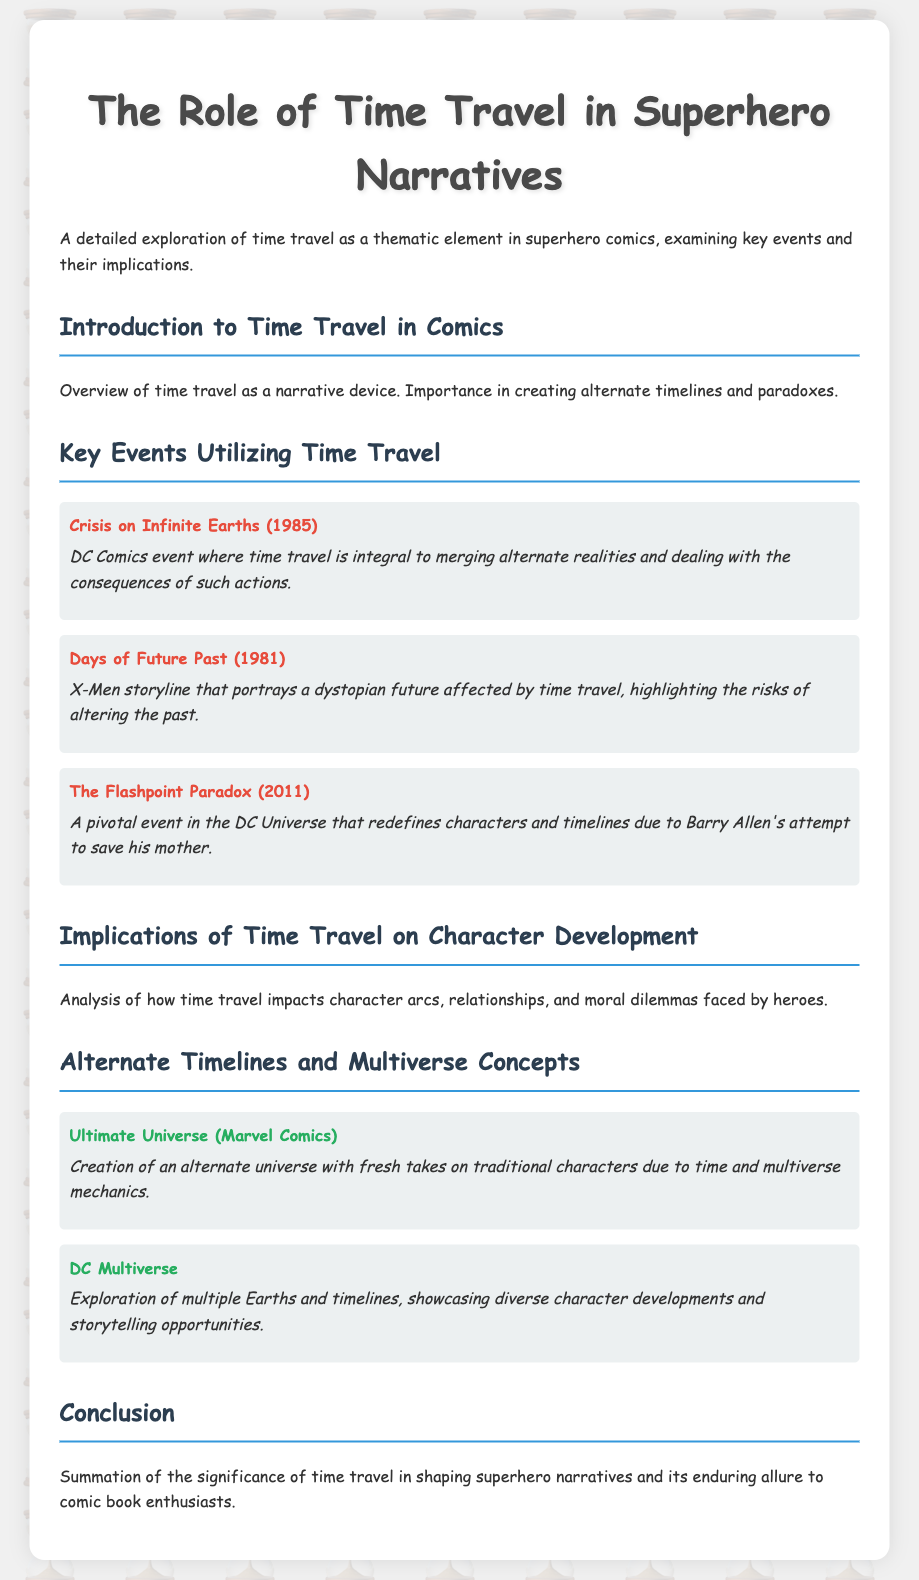What is the title of the document? The title is specified in the header tag of the document.
Answer: The Role of Time Travel in Superhero Narratives What year did the event "Crisis on Infinite Earths" occur? The year of the event is mentioned in the description of key events.
Answer: 1985 Which comic book series features the storyline "Days of Future Past"? The series is identified in the document among key events that utilize time travel.
Answer: X-Men What is the significance of "Flashpoint Paradox"? The significance is explained in the context of timelines and character redefining.
Answer: Redefines characters and timelines What alternate universe is created due to multiverse mechanics in Marvel Comics? The document names this alternate universe specifically in the discussion of multiverse concepts.
Answer: Ultimate Universe How does time travel generally affect character development? The implications are summarized under the section dedicated to character development impacts.
Answer: Impacts character arcs and moral dilemmas What are the two concepts discussed under "Alternate Timelines and Multiverse Concepts"? These are explicitly listed in the document, highlighting different comic book universes.
Answer: Ultimate Universe and DC Multiverse What is the publication year of "Days of Future Past"? The publication year is explicitly mentioned in the document under key events.
Answer: 1981 What is the general overview of time travel in comics? The overview is described in the introduction section of the document.
Answer: A narrative device creating alternate timelines and paradoxes 